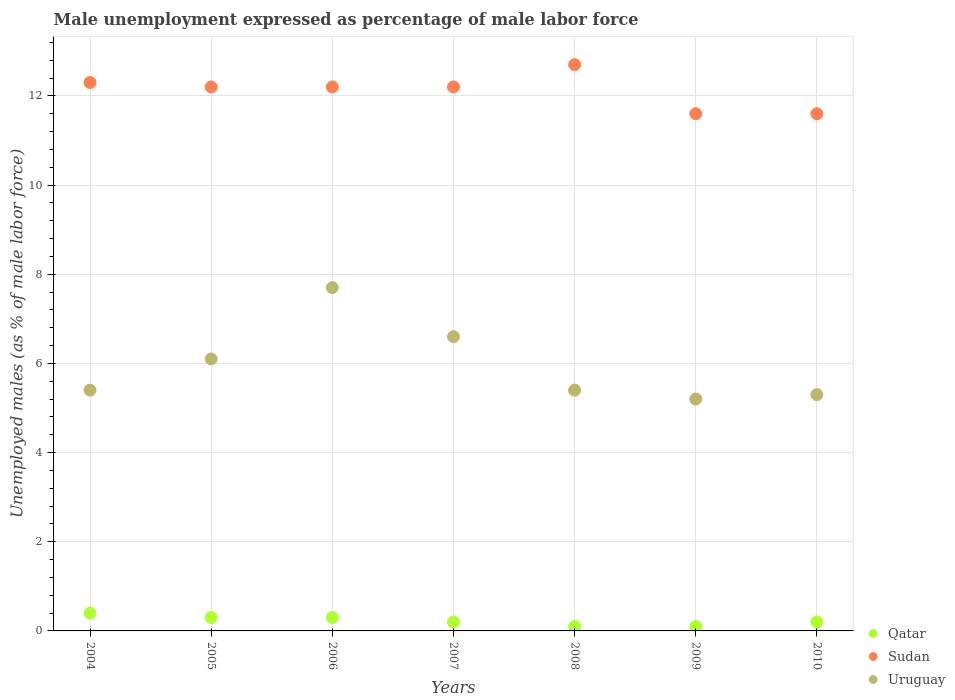What is the unemployment in males in in Qatar in 2006?
Give a very brief answer. 0.3. Across all years, what is the maximum unemployment in males in in Sudan?
Your response must be concise. 12.7. Across all years, what is the minimum unemployment in males in in Uruguay?
Your response must be concise. 5.2. What is the total unemployment in males in in Uruguay in the graph?
Provide a succinct answer. 41.7. What is the difference between the unemployment in males in in Qatar in 2006 and the unemployment in males in in Uruguay in 2009?
Provide a succinct answer. -4.9. What is the average unemployment in males in in Sudan per year?
Offer a very short reply. 12.11. In the year 2009, what is the difference between the unemployment in males in in Qatar and unemployment in males in in Uruguay?
Offer a terse response. -5.1. In how many years, is the unemployment in males in in Uruguay greater than 10 %?
Provide a short and direct response. 0. What is the ratio of the unemployment in males in in Qatar in 2007 to that in 2010?
Provide a succinct answer. 1. Is the unemployment in males in in Uruguay in 2007 less than that in 2009?
Keep it short and to the point. No. Is the difference between the unemployment in males in in Qatar in 2005 and 2009 greater than the difference between the unemployment in males in in Uruguay in 2005 and 2009?
Your response must be concise. No. What is the difference between the highest and the second highest unemployment in males in in Uruguay?
Provide a short and direct response. 1.1. What is the difference between the highest and the lowest unemployment in males in in Qatar?
Provide a short and direct response. 0.3. Is the sum of the unemployment in males in in Uruguay in 2004 and 2008 greater than the maximum unemployment in males in in Qatar across all years?
Your answer should be very brief. Yes. Is the unemployment in males in in Qatar strictly less than the unemployment in males in in Uruguay over the years?
Offer a very short reply. Yes. How many dotlines are there?
Offer a very short reply. 3. Does the graph contain grids?
Your answer should be very brief. Yes. Where does the legend appear in the graph?
Provide a short and direct response. Bottom right. How many legend labels are there?
Your answer should be compact. 3. How are the legend labels stacked?
Provide a short and direct response. Vertical. What is the title of the graph?
Provide a succinct answer. Male unemployment expressed as percentage of male labor force. What is the label or title of the X-axis?
Keep it short and to the point. Years. What is the label or title of the Y-axis?
Ensure brevity in your answer.  Unemployed males (as % of male labor force). What is the Unemployed males (as % of male labor force) in Qatar in 2004?
Make the answer very short. 0.4. What is the Unemployed males (as % of male labor force) of Sudan in 2004?
Give a very brief answer. 12.3. What is the Unemployed males (as % of male labor force) in Uruguay in 2004?
Provide a succinct answer. 5.4. What is the Unemployed males (as % of male labor force) of Qatar in 2005?
Offer a terse response. 0.3. What is the Unemployed males (as % of male labor force) in Sudan in 2005?
Give a very brief answer. 12.2. What is the Unemployed males (as % of male labor force) in Uruguay in 2005?
Your response must be concise. 6.1. What is the Unemployed males (as % of male labor force) in Qatar in 2006?
Provide a succinct answer. 0.3. What is the Unemployed males (as % of male labor force) of Sudan in 2006?
Ensure brevity in your answer.  12.2. What is the Unemployed males (as % of male labor force) of Uruguay in 2006?
Keep it short and to the point. 7.7. What is the Unemployed males (as % of male labor force) in Qatar in 2007?
Your response must be concise. 0.2. What is the Unemployed males (as % of male labor force) in Sudan in 2007?
Ensure brevity in your answer.  12.2. What is the Unemployed males (as % of male labor force) in Uruguay in 2007?
Ensure brevity in your answer.  6.6. What is the Unemployed males (as % of male labor force) in Qatar in 2008?
Your answer should be very brief. 0.1. What is the Unemployed males (as % of male labor force) of Sudan in 2008?
Your response must be concise. 12.7. What is the Unemployed males (as % of male labor force) in Uruguay in 2008?
Provide a short and direct response. 5.4. What is the Unemployed males (as % of male labor force) of Qatar in 2009?
Keep it short and to the point. 0.1. What is the Unemployed males (as % of male labor force) in Sudan in 2009?
Keep it short and to the point. 11.6. What is the Unemployed males (as % of male labor force) in Uruguay in 2009?
Provide a succinct answer. 5.2. What is the Unemployed males (as % of male labor force) in Qatar in 2010?
Ensure brevity in your answer.  0.2. What is the Unemployed males (as % of male labor force) in Sudan in 2010?
Offer a very short reply. 11.6. What is the Unemployed males (as % of male labor force) of Uruguay in 2010?
Provide a short and direct response. 5.3. Across all years, what is the maximum Unemployed males (as % of male labor force) in Qatar?
Ensure brevity in your answer.  0.4. Across all years, what is the maximum Unemployed males (as % of male labor force) in Sudan?
Keep it short and to the point. 12.7. Across all years, what is the maximum Unemployed males (as % of male labor force) in Uruguay?
Your answer should be compact. 7.7. Across all years, what is the minimum Unemployed males (as % of male labor force) in Qatar?
Provide a succinct answer. 0.1. Across all years, what is the minimum Unemployed males (as % of male labor force) in Sudan?
Offer a terse response. 11.6. Across all years, what is the minimum Unemployed males (as % of male labor force) in Uruguay?
Provide a succinct answer. 5.2. What is the total Unemployed males (as % of male labor force) in Qatar in the graph?
Make the answer very short. 1.6. What is the total Unemployed males (as % of male labor force) in Sudan in the graph?
Make the answer very short. 84.8. What is the total Unemployed males (as % of male labor force) of Uruguay in the graph?
Offer a terse response. 41.7. What is the difference between the Unemployed males (as % of male labor force) of Uruguay in 2004 and that in 2005?
Ensure brevity in your answer.  -0.7. What is the difference between the Unemployed males (as % of male labor force) of Qatar in 2004 and that in 2006?
Provide a short and direct response. 0.1. What is the difference between the Unemployed males (as % of male labor force) in Uruguay in 2004 and that in 2006?
Keep it short and to the point. -2.3. What is the difference between the Unemployed males (as % of male labor force) in Sudan in 2004 and that in 2007?
Your response must be concise. 0.1. What is the difference between the Unemployed males (as % of male labor force) in Uruguay in 2004 and that in 2007?
Your answer should be very brief. -1.2. What is the difference between the Unemployed males (as % of male labor force) in Sudan in 2004 and that in 2009?
Provide a succinct answer. 0.7. What is the difference between the Unemployed males (as % of male labor force) of Uruguay in 2004 and that in 2009?
Your response must be concise. 0.2. What is the difference between the Unemployed males (as % of male labor force) in Uruguay in 2004 and that in 2010?
Your answer should be very brief. 0.1. What is the difference between the Unemployed males (as % of male labor force) of Qatar in 2005 and that in 2006?
Offer a terse response. 0. What is the difference between the Unemployed males (as % of male labor force) of Sudan in 2005 and that in 2006?
Offer a terse response. 0. What is the difference between the Unemployed males (as % of male labor force) in Qatar in 2005 and that in 2007?
Keep it short and to the point. 0.1. What is the difference between the Unemployed males (as % of male labor force) in Uruguay in 2005 and that in 2008?
Your answer should be compact. 0.7. What is the difference between the Unemployed males (as % of male labor force) of Sudan in 2005 and that in 2009?
Provide a short and direct response. 0.6. What is the difference between the Unemployed males (as % of male labor force) in Uruguay in 2005 and that in 2009?
Keep it short and to the point. 0.9. What is the difference between the Unemployed males (as % of male labor force) of Qatar in 2005 and that in 2010?
Offer a very short reply. 0.1. What is the difference between the Unemployed males (as % of male labor force) of Sudan in 2005 and that in 2010?
Provide a succinct answer. 0.6. What is the difference between the Unemployed males (as % of male labor force) in Uruguay in 2005 and that in 2010?
Keep it short and to the point. 0.8. What is the difference between the Unemployed males (as % of male labor force) in Qatar in 2006 and that in 2007?
Provide a succinct answer. 0.1. What is the difference between the Unemployed males (as % of male labor force) of Uruguay in 2006 and that in 2007?
Give a very brief answer. 1.1. What is the difference between the Unemployed males (as % of male labor force) of Qatar in 2006 and that in 2008?
Keep it short and to the point. 0.2. What is the difference between the Unemployed males (as % of male labor force) in Sudan in 2006 and that in 2008?
Your answer should be very brief. -0.5. What is the difference between the Unemployed males (as % of male labor force) in Sudan in 2006 and that in 2009?
Give a very brief answer. 0.6. What is the difference between the Unemployed males (as % of male labor force) in Uruguay in 2006 and that in 2009?
Make the answer very short. 2.5. What is the difference between the Unemployed males (as % of male labor force) in Qatar in 2006 and that in 2010?
Keep it short and to the point. 0.1. What is the difference between the Unemployed males (as % of male labor force) in Sudan in 2006 and that in 2010?
Your response must be concise. 0.6. What is the difference between the Unemployed males (as % of male labor force) in Uruguay in 2006 and that in 2010?
Your answer should be compact. 2.4. What is the difference between the Unemployed males (as % of male labor force) in Qatar in 2007 and that in 2008?
Ensure brevity in your answer.  0.1. What is the difference between the Unemployed males (as % of male labor force) of Sudan in 2007 and that in 2009?
Ensure brevity in your answer.  0.6. What is the difference between the Unemployed males (as % of male labor force) in Uruguay in 2007 and that in 2009?
Provide a succinct answer. 1.4. What is the difference between the Unemployed males (as % of male labor force) in Uruguay in 2007 and that in 2010?
Make the answer very short. 1.3. What is the difference between the Unemployed males (as % of male labor force) in Qatar in 2008 and that in 2009?
Your answer should be compact. 0. What is the difference between the Unemployed males (as % of male labor force) of Uruguay in 2008 and that in 2009?
Your answer should be very brief. 0.2. What is the difference between the Unemployed males (as % of male labor force) of Qatar in 2008 and that in 2010?
Offer a very short reply. -0.1. What is the difference between the Unemployed males (as % of male labor force) of Qatar in 2004 and the Unemployed males (as % of male labor force) of Uruguay in 2005?
Ensure brevity in your answer.  -5.7. What is the difference between the Unemployed males (as % of male labor force) of Qatar in 2004 and the Unemployed males (as % of male labor force) of Sudan in 2006?
Make the answer very short. -11.8. What is the difference between the Unemployed males (as % of male labor force) of Qatar in 2004 and the Unemployed males (as % of male labor force) of Uruguay in 2006?
Keep it short and to the point. -7.3. What is the difference between the Unemployed males (as % of male labor force) in Sudan in 2004 and the Unemployed males (as % of male labor force) in Uruguay in 2006?
Ensure brevity in your answer.  4.6. What is the difference between the Unemployed males (as % of male labor force) of Qatar in 2004 and the Unemployed males (as % of male labor force) of Sudan in 2007?
Give a very brief answer. -11.8. What is the difference between the Unemployed males (as % of male labor force) of Qatar in 2004 and the Unemployed males (as % of male labor force) of Uruguay in 2007?
Offer a terse response. -6.2. What is the difference between the Unemployed males (as % of male labor force) in Sudan in 2004 and the Unemployed males (as % of male labor force) in Uruguay in 2008?
Provide a succinct answer. 6.9. What is the difference between the Unemployed males (as % of male labor force) in Qatar in 2004 and the Unemployed males (as % of male labor force) in Sudan in 2009?
Give a very brief answer. -11.2. What is the difference between the Unemployed males (as % of male labor force) in Sudan in 2004 and the Unemployed males (as % of male labor force) in Uruguay in 2009?
Provide a succinct answer. 7.1. What is the difference between the Unemployed males (as % of male labor force) of Qatar in 2004 and the Unemployed males (as % of male labor force) of Sudan in 2010?
Provide a short and direct response. -11.2. What is the difference between the Unemployed males (as % of male labor force) in Qatar in 2004 and the Unemployed males (as % of male labor force) in Uruguay in 2010?
Offer a terse response. -4.9. What is the difference between the Unemployed males (as % of male labor force) of Sudan in 2004 and the Unemployed males (as % of male labor force) of Uruguay in 2010?
Your answer should be very brief. 7. What is the difference between the Unemployed males (as % of male labor force) in Qatar in 2005 and the Unemployed males (as % of male labor force) in Sudan in 2006?
Provide a succinct answer. -11.9. What is the difference between the Unemployed males (as % of male labor force) of Qatar in 2005 and the Unemployed males (as % of male labor force) of Uruguay in 2006?
Make the answer very short. -7.4. What is the difference between the Unemployed males (as % of male labor force) of Qatar in 2005 and the Unemployed males (as % of male labor force) of Sudan in 2007?
Your answer should be compact. -11.9. What is the difference between the Unemployed males (as % of male labor force) in Qatar in 2005 and the Unemployed males (as % of male labor force) in Sudan in 2008?
Ensure brevity in your answer.  -12.4. What is the difference between the Unemployed males (as % of male labor force) of Qatar in 2005 and the Unemployed males (as % of male labor force) of Sudan in 2009?
Offer a very short reply. -11.3. What is the difference between the Unemployed males (as % of male labor force) in Qatar in 2005 and the Unemployed males (as % of male labor force) in Uruguay in 2009?
Keep it short and to the point. -4.9. What is the difference between the Unemployed males (as % of male labor force) of Sudan in 2005 and the Unemployed males (as % of male labor force) of Uruguay in 2009?
Keep it short and to the point. 7. What is the difference between the Unemployed males (as % of male labor force) of Qatar in 2005 and the Unemployed males (as % of male labor force) of Sudan in 2010?
Provide a succinct answer. -11.3. What is the difference between the Unemployed males (as % of male labor force) in Sudan in 2005 and the Unemployed males (as % of male labor force) in Uruguay in 2010?
Offer a terse response. 6.9. What is the difference between the Unemployed males (as % of male labor force) of Qatar in 2006 and the Unemployed males (as % of male labor force) of Sudan in 2007?
Ensure brevity in your answer.  -11.9. What is the difference between the Unemployed males (as % of male labor force) in Qatar in 2006 and the Unemployed males (as % of male labor force) in Uruguay in 2007?
Ensure brevity in your answer.  -6.3. What is the difference between the Unemployed males (as % of male labor force) of Sudan in 2006 and the Unemployed males (as % of male labor force) of Uruguay in 2007?
Keep it short and to the point. 5.6. What is the difference between the Unemployed males (as % of male labor force) in Sudan in 2006 and the Unemployed males (as % of male labor force) in Uruguay in 2008?
Your answer should be compact. 6.8. What is the difference between the Unemployed males (as % of male labor force) in Qatar in 2006 and the Unemployed males (as % of male labor force) in Uruguay in 2009?
Ensure brevity in your answer.  -4.9. What is the difference between the Unemployed males (as % of male labor force) in Qatar in 2006 and the Unemployed males (as % of male labor force) in Sudan in 2010?
Offer a terse response. -11.3. What is the difference between the Unemployed males (as % of male labor force) in Sudan in 2006 and the Unemployed males (as % of male labor force) in Uruguay in 2010?
Give a very brief answer. 6.9. What is the difference between the Unemployed males (as % of male labor force) of Qatar in 2008 and the Unemployed males (as % of male labor force) of Sudan in 2009?
Your response must be concise. -11.5. What is the difference between the Unemployed males (as % of male labor force) in Qatar in 2008 and the Unemployed males (as % of male labor force) in Uruguay in 2009?
Provide a short and direct response. -5.1. What is the difference between the Unemployed males (as % of male labor force) of Qatar in 2008 and the Unemployed males (as % of male labor force) of Sudan in 2010?
Make the answer very short. -11.5. What is the difference between the Unemployed males (as % of male labor force) of Qatar in 2008 and the Unemployed males (as % of male labor force) of Uruguay in 2010?
Offer a very short reply. -5.2. What is the difference between the Unemployed males (as % of male labor force) of Qatar in 2009 and the Unemployed males (as % of male labor force) of Sudan in 2010?
Your answer should be compact. -11.5. What is the difference between the Unemployed males (as % of male labor force) of Qatar in 2009 and the Unemployed males (as % of male labor force) of Uruguay in 2010?
Your answer should be very brief. -5.2. What is the difference between the Unemployed males (as % of male labor force) in Sudan in 2009 and the Unemployed males (as % of male labor force) in Uruguay in 2010?
Ensure brevity in your answer.  6.3. What is the average Unemployed males (as % of male labor force) in Qatar per year?
Your answer should be compact. 0.23. What is the average Unemployed males (as % of male labor force) in Sudan per year?
Your answer should be very brief. 12.11. What is the average Unemployed males (as % of male labor force) in Uruguay per year?
Keep it short and to the point. 5.96. In the year 2004, what is the difference between the Unemployed males (as % of male labor force) in Qatar and Unemployed males (as % of male labor force) in Sudan?
Your answer should be very brief. -11.9. In the year 2004, what is the difference between the Unemployed males (as % of male labor force) of Qatar and Unemployed males (as % of male labor force) of Uruguay?
Offer a terse response. -5. In the year 2004, what is the difference between the Unemployed males (as % of male labor force) of Sudan and Unemployed males (as % of male labor force) of Uruguay?
Provide a succinct answer. 6.9. In the year 2005, what is the difference between the Unemployed males (as % of male labor force) in Qatar and Unemployed males (as % of male labor force) in Sudan?
Offer a very short reply. -11.9. In the year 2005, what is the difference between the Unemployed males (as % of male labor force) of Qatar and Unemployed males (as % of male labor force) of Uruguay?
Provide a short and direct response. -5.8. In the year 2005, what is the difference between the Unemployed males (as % of male labor force) of Sudan and Unemployed males (as % of male labor force) of Uruguay?
Your response must be concise. 6.1. In the year 2006, what is the difference between the Unemployed males (as % of male labor force) of Sudan and Unemployed males (as % of male labor force) of Uruguay?
Keep it short and to the point. 4.5. In the year 2007, what is the difference between the Unemployed males (as % of male labor force) in Qatar and Unemployed males (as % of male labor force) in Sudan?
Ensure brevity in your answer.  -12. In the year 2007, what is the difference between the Unemployed males (as % of male labor force) of Sudan and Unemployed males (as % of male labor force) of Uruguay?
Offer a very short reply. 5.6. In the year 2008, what is the difference between the Unemployed males (as % of male labor force) of Qatar and Unemployed males (as % of male labor force) of Sudan?
Keep it short and to the point. -12.6. In the year 2008, what is the difference between the Unemployed males (as % of male labor force) in Sudan and Unemployed males (as % of male labor force) in Uruguay?
Your answer should be compact. 7.3. In the year 2010, what is the difference between the Unemployed males (as % of male labor force) in Qatar and Unemployed males (as % of male labor force) in Sudan?
Keep it short and to the point. -11.4. In the year 2010, what is the difference between the Unemployed males (as % of male labor force) of Qatar and Unemployed males (as % of male labor force) of Uruguay?
Give a very brief answer. -5.1. What is the ratio of the Unemployed males (as % of male labor force) in Sudan in 2004 to that in 2005?
Offer a very short reply. 1.01. What is the ratio of the Unemployed males (as % of male labor force) in Uruguay in 2004 to that in 2005?
Your answer should be compact. 0.89. What is the ratio of the Unemployed males (as % of male labor force) of Sudan in 2004 to that in 2006?
Offer a terse response. 1.01. What is the ratio of the Unemployed males (as % of male labor force) in Uruguay in 2004 to that in 2006?
Make the answer very short. 0.7. What is the ratio of the Unemployed males (as % of male labor force) of Qatar in 2004 to that in 2007?
Make the answer very short. 2. What is the ratio of the Unemployed males (as % of male labor force) of Sudan in 2004 to that in 2007?
Provide a succinct answer. 1.01. What is the ratio of the Unemployed males (as % of male labor force) of Uruguay in 2004 to that in 2007?
Ensure brevity in your answer.  0.82. What is the ratio of the Unemployed males (as % of male labor force) of Sudan in 2004 to that in 2008?
Your answer should be compact. 0.97. What is the ratio of the Unemployed males (as % of male labor force) of Uruguay in 2004 to that in 2008?
Offer a very short reply. 1. What is the ratio of the Unemployed males (as % of male labor force) of Qatar in 2004 to that in 2009?
Your answer should be compact. 4. What is the ratio of the Unemployed males (as % of male labor force) in Sudan in 2004 to that in 2009?
Your response must be concise. 1.06. What is the ratio of the Unemployed males (as % of male labor force) of Qatar in 2004 to that in 2010?
Provide a short and direct response. 2. What is the ratio of the Unemployed males (as % of male labor force) in Sudan in 2004 to that in 2010?
Provide a succinct answer. 1.06. What is the ratio of the Unemployed males (as % of male labor force) of Uruguay in 2004 to that in 2010?
Provide a succinct answer. 1.02. What is the ratio of the Unemployed males (as % of male labor force) in Sudan in 2005 to that in 2006?
Offer a very short reply. 1. What is the ratio of the Unemployed males (as % of male labor force) of Uruguay in 2005 to that in 2006?
Provide a short and direct response. 0.79. What is the ratio of the Unemployed males (as % of male labor force) in Uruguay in 2005 to that in 2007?
Offer a terse response. 0.92. What is the ratio of the Unemployed males (as % of male labor force) in Sudan in 2005 to that in 2008?
Offer a very short reply. 0.96. What is the ratio of the Unemployed males (as % of male labor force) of Uruguay in 2005 to that in 2008?
Make the answer very short. 1.13. What is the ratio of the Unemployed males (as % of male labor force) of Sudan in 2005 to that in 2009?
Ensure brevity in your answer.  1.05. What is the ratio of the Unemployed males (as % of male labor force) of Uruguay in 2005 to that in 2009?
Your answer should be compact. 1.17. What is the ratio of the Unemployed males (as % of male labor force) of Sudan in 2005 to that in 2010?
Keep it short and to the point. 1.05. What is the ratio of the Unemployed males (as % of male labor force) of Uruguay in 2005 to that in 2010?
Give a very brief answer. 1.15. What is the ratio of the Unemployed males (as % of male labor force) in Uruguay in 2006 to that in 2007?
Offer a terse response. 1.17. What is the ratio of the Unemployed males (as % of male labor force) in Qatar in 2006 to that in 2008?
Give a very brief answer. 3. What is the ratio of the Unemployed males (as % of male labor force) of Sudan in 2006 to that in 2008?
Your response must be concise. 0.96. What is the ratio of the Unemployed males (as % of male labor force) of Uruguay in 2006 to that in 2008?
Provide a succinct answer. 1.43. What is the ratio of the Unemployed males (as % of male labor force) of Qatar in 2006 to that in 2009?
Offer a very short reply. 3. What is the ratio of the Unemployed males (as % of male labor force) in Sudan in 2006 to that in 2009?
Make the answer very short. 1.05. What is the ratio of the Unemployed males (as % of male labor force) of Uruguay in 2006 to that in 2009?
Your response must be concise. 1.48. What is the ratio of the Unemployed males (as % of male labor force) of Qatar in 2006 to that in 2010?
Your response must be concise. 1.5. What is the ratio of the Unemployed males (as % of male labor force) in Sudan in 2006 to that in 2010?
Keep it short and to the point. 1.05. What is the ratio of the Unemployed males (as % of male labor force) in Uruguay in 2006 to that in 2010?
Your answer should be very brief. 1.45. What is the ratio of the Unemployed males (as % of male labor force) of Qatar in 2007 to that in 2008?
Your response must be concise. 2. What is the ratio of the Unemployed males (as % of male labor force) of Sudan in 2007 to that in 2008?
Offer a very short reply. 0.96. What is the ratio of the Unemployed males (as % of male labor force) in Uruguay in 2007 to that in 2008?
Keep it short and to the point. 1.22. What is the ratio of the Unemployed males (as % of male labor force) of Qatar in 2007 to that in 2009?
Provide a succinct answer. 2. What is the ratio of the Unemployed males (as % of male labor force) in Sudan in 2007 to that in 2009?
Keep it short and to the point. 1.05. What is the ratio of the Unemployed males (as % of male labor force) in Uruguay in 2007 to that in 2009?
Provide a succinct answer. 1.27. What is the ratio of the Unemployed males (as % of male labor force) of Qatar in 2007 to that in 2010?
Give a very brief answer. 1. What is the ratio of the Unemployed males (as % of male labor force) in Sudan in 2007 to that in 2010?
Offer a very short reply. 1.05. What is the ratio of the Unemployed males (as % of male labor force) of Uruguay in 2007 to that in 2010?
Your response must be concise. 1.25. What is the ratio of the Unemployed males (as % of male labor force) of Qatar in 2008 to that in 2009?
Your answer should be very brief. 1. What is the ratio of the Unemployed males (as % of male labor force) of Sudan in 2008 to that in 2009?
Offer a very short reply. 1.09. What is the ratio of the Unemployed males (as % of male labor force) of Uruguay in 2008 to that in 2009?
Ensure brevity in your answer.  1.04. What is the ratio of the Unemployed males (as % of male labor force) in Qatar in 2008 to that in 2010?
Your response must be concise. 0.5. What is the ratio of the Unemployed males (as % of male labor force) in Sudan in 2008 to that in 2010?
Provide a succinct answer. 1.09. What is the ratio of the Unemployed males (as % of male labor force) in Uruguay in 2008 to that in 2010?
Make the answer very short. 1.02. What is the ratio of the Unemployed males (as % of male labor force) in Qatar in 2009 to that in 2010?
Offer a terse response. 0.5. What is the ratio of the Unemployed males (as % of male labor force) of Sudan in 2009 to that in 2010?
Make the answer very short. 1. What is the ratio of the Unemployed males (as % of male labor force) of Uruguay in 2009 to that in 2010?
Offer a terse response. 0.98. What is the difference between the highest and the second highest Unemployed males (as % of male labor force) of Qatar?
Provide a succinct answer. 0.1. What is the difference between the highest and the second highest Unemployed males (as % of male labor force) of Sudan?
Your response must be concise. 0.4. What is the difference between the highest and the second highest Unemployed males (as % of male labor force) of Uruguay?
Your answer should be very brief. 1.1. What is the difference between the highest and the lowest Unemployed males (as % of male labor force) in Qatar?
Offer a terse response. 0.3. What is the difference between the highest and the lowest Unemployed males (as % of male labor force) in Uruguay?
Keep it short and to the point. 2.5. 